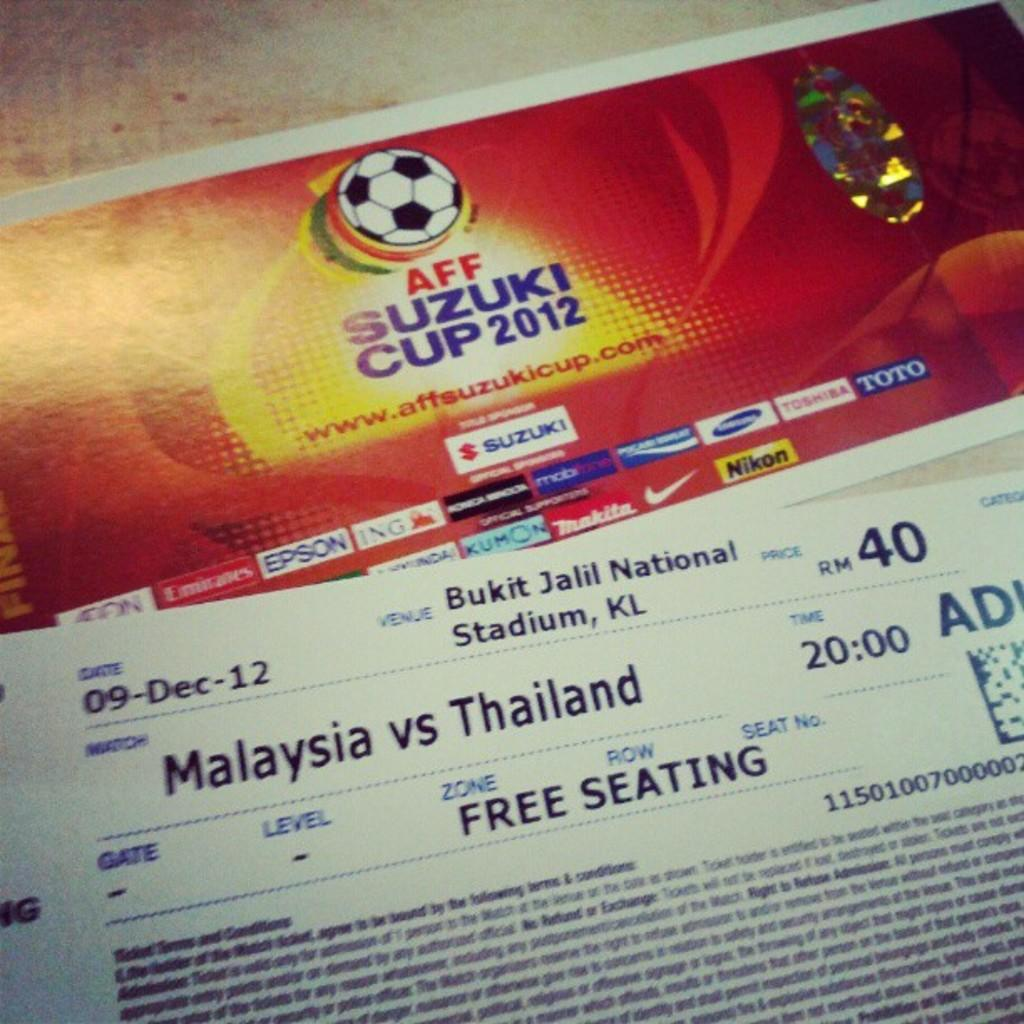What objects can be seen in the image? There are tickets in the image. Where are the tickets located? The tickets are placed on a table. What type of cord is used to secure the agreement in the image? There is no cord or agreement present in the image; it only features tickets placed on a table. 